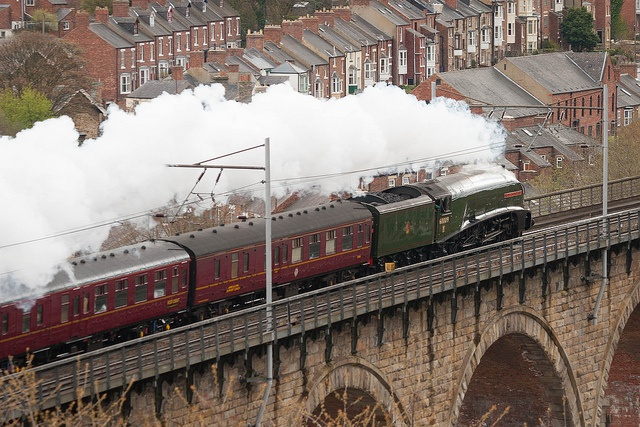Describe the objects in this image and their specific colors. I can see a train in brown, black, maroon, gray, and darkgray tones in this image. 